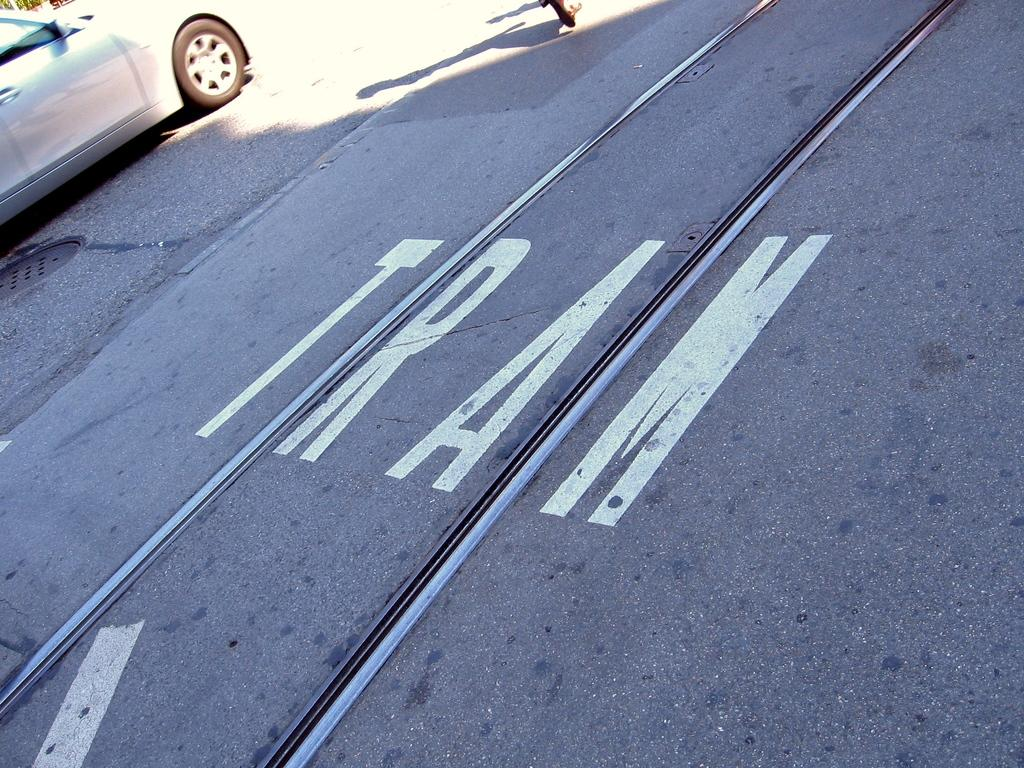What is the main feature of the image? There is a road in the image. Can you describe any vehicles present in the image? There is a white color car in the image. How many trees are growing in the car in the image? There are no trees growing in the car in the image, as it is a white color car without any trees inside. 